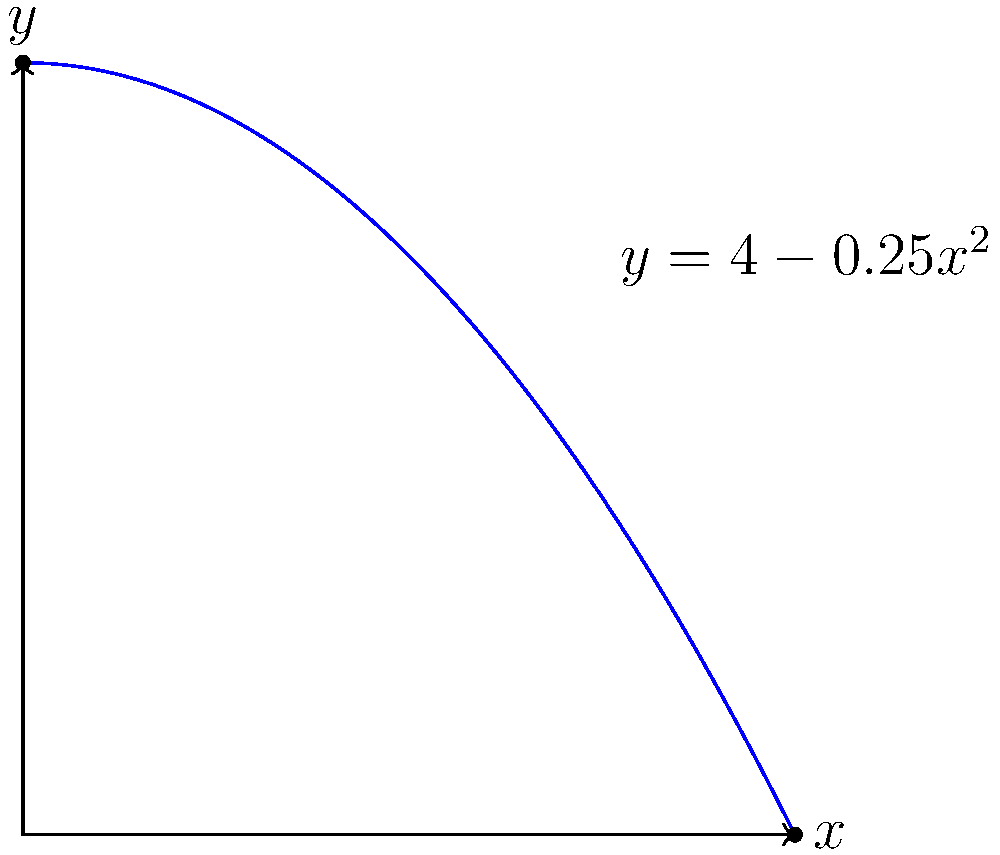As a streetball player, you're analyzing the trajectory of a perfect arc shot. The path of the ball can be modeled by the function $y = 4 - 0.25x^2$, where $x$ and $y$ are measured in meters. What is the arc length of the shot from release point (0, 4) to the basket (4, 0)? To calculate the arc length of the curved shot trajectory, we'll use the arc length formula for a function $y = f(x)$ from $a$ to $b$:

$$ L = \int_{a}^{b} \sqrt{1 + \left(\frac{dy}{dx}\right)^2} dx $$

Steps:
1) First, find $\frac{dy}{dx}$:
   $y = 4 - 0.25x^2$
   $\frac{dy}{dx} = -0.5x$

2) Substitute into the arc length formula:
   $$ L = \int_{0}^{4} \sqrt{1 + (-0.5x)^2} dx $$

3) Simplify under the square root:
   $$ L = \int_{0}^{4} \sqrt{1 + 0.25x^2} dx $$

4) This integral doesn't have an elementary antiderivative, so we need to use numerical integration methods or special functions. The exact result involves the hyperbolic sine function:

   $$ L = 2\left[x\sqrt{1+0.25x^2} + 2\sinh^{-1}(0.5x)\right]_0^4 $$

5) Evaluating at the limits:
   $$ L = 2\left[(4\sqrt{1+0.25(4)^2} + 2\sinh^{-1}(0.5(4))) - (0\sqrt{1+0.25(0)^2} + 2\sinh^{-1}(0))\right] $$

6) Simplify:
   $$ L = 2(4\sqrt{5} + 2\sinh^{-1}(2)) \approx 4.2802 \text{ meters} $$
Answer: $4.2802$ meters 